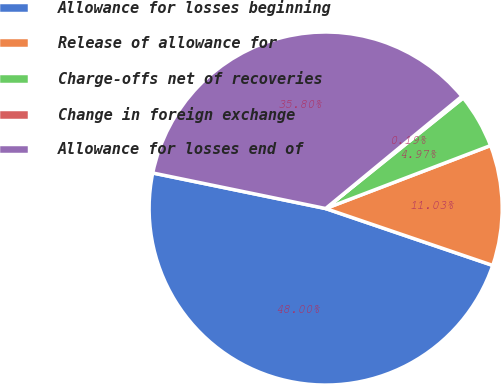Convert chart to OTSL. <chart><loc_0><loc_0><loc_500><loc_500><pie_chart><fcel>Allowance for losses beginning<fcel>Release of allowance for<fcel>Charge-offs net of recoveries<fcel>Change in foreign exchange<fcel>Allowance for losses end of<nl><fcel>48.0%<fcel>11.03%<fcel>4.97%<fcel>0.19%<fcel>35.8%<nl></chart> 